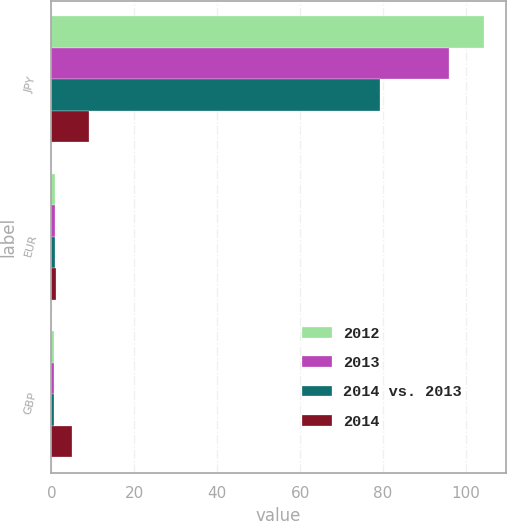Convert chart to OTSL. <chart><loc_0><loc_0><loc_500><loc_500><stacked_bar_chart><ecel><fcel>JPY<fcel>EUR<fcel>GBP<nl><fcel>2012<fcel>104.43<fcel>0.75<fcel>0.61<nl><fcel>2013<fcel>95.86<fcel>0.76<fcel>0.64<nl><fcel>2014 vs. 2013<fcel>79.32<fcel>0.78<fcel>0.63<nl><fcel>2014<fcel>9<fcel>1<fcel>5<nl></chart> 